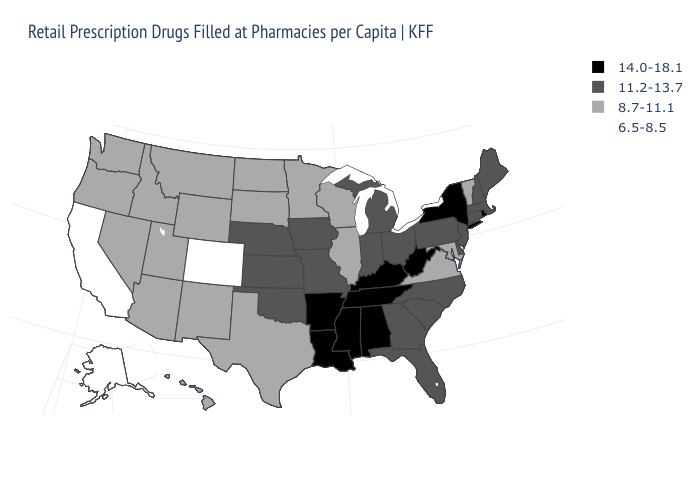Among the states that border Maryland , which have the lowest value?
Short answer required. Virginia. How many symbols are there in the legend?
Give a very brief answer. 4. Does Indiana have the lowest value in the MidWest?
Short answer required. No. What is the value of New Mexico?
Keep it brief. 8.7-11.1. How many symbols are there in the legend?
Quick response, please. 4. Among the states that border Massachusetts , does Connecticut have the lowest value?
Short answer required. No. What is the value of Pennsylvania?
Give a very brief answer. 11.2-13.7. Name the states that have a value in the range 6.5-8.5?
Answer briefly. Alaska, California, Colorado. Name the states that have a value in the range 6.5-8.5?
Answer briefly. Alaska, California, Colorado. Does Vermont have the highest value in the Northeast?
Write a very short answer. No. Among the states that border Virginia , which have the lowest value?
Write a very short answer. Maryland. Name the states that have a value in the range 6.5-8.5?
Quick response, please. Alaska, California, Colorado. What is the lowest value in the West?
Quick response, please. 6.5-8.5. Does Montana have the highest value in the USA?
Concise answer only. No. Name the states that have a value in the range 6.5-8.5?
Keep it brief. Alaska, California, Colorado. 